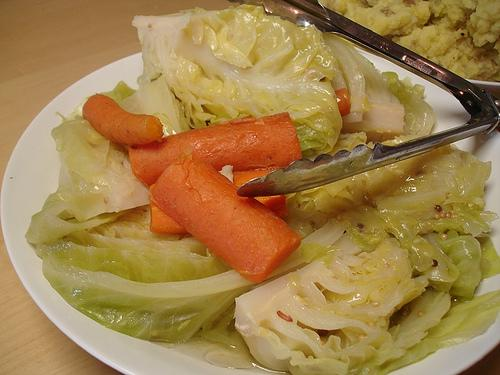What is the visible texture of the table's surface? The table has a visible woodgrain texture and is light tan in color. Identify an object in the background of the image. There is a dish of unidentified fried fish in the background. Based on the visual details of the food, determine if it is cooked or raw. The visual details suggest that the food, both the cabbage, and carrot slices, are cooked. How would you rate the quality of the image's composition? The image composition is well-structured, with a focus on the main objects and proper placement of the background elements. What is the main sentiment evoked by the image of the food presented? The main sentiment evoked by the image is a feeling of a healthy and appetizing meal. Describe the interaction between the tongs and the food on the plate. The silver tongs are resting on top of the heap of cabbage and carrot slices, leaning against the cabbage. What are the main objects in the image and their colors? The main objects in the image are silver tongs, boiled cabbage with a yellow-green color, and orange carrot slices, all on a white round plate on a light tan woodgrained table. Infer a possible reason for the presence of the tongs on the plate. The tongs might be present on the plate to facilitate easy serving or handling of the food. Count the number of carrot pieces on the plate. There are at least 10 pieces of orange carrot on the plate. Provide a detailed description of the food displayed. The food displayed consists of seasoned boiled cabbage and cooked orange carrot segments, piled together on a white round plate, and a silver tongs resting on top of the food. What do you think about the green fork inserted into the seasoned boiled cabbage and carrots? No, it's not mentioned in the image. What is the color and texture of the table the plate is sitting on? The table is light tan in color with a woodgrain texture. Is there any carrot on top of the pile of cabbage? Yes, a piece of orange carrot is on top of the cabbage. Describe the colors and materials of the tongs and the table. The tongs are silver, and the table is light tan with a woodgrain texture. Provide a brief description of the scene in the image. A round white plate with seasoned boiled cabbage and cooked orange carrot segments is placed on a light tan woodgrained table, with silver tongs resting on the food and a dish of fried fish in the background. Based on the image, what kind of activity can you infer is happening or about to happen? Someone is about to serve and eat the cooked vegetables using the silver tongs. Examine the plate holding the food and describe its shape and color. The plate is round and white. What type of vegetable is resting on top of the pile of cabbage? A piece of orange carrot. Write a creative story that is based on the image. Once upon a time in a quaint village, there was a magical cook who could turn any dish into a delicious and healthy treat. One day, as she scrambled to prepare a meal for the visiting queen, she chose a simple combination of boiled cabbage and cooked carrot segments arranged on a round white plate. The cook added secret seasonings that gave the cabbage a yellow-green glow, and she transformed unassuming carrots into radiant orange jewels. A pair of enchanted silver tongs lay atop, eager to serve. Paired with a dish of elusive delicacy, the humble meal enchanted the queen, healing her weariness, and winning her gratitude. Thus, the cook's simple dish became a legend in the village, and her fame spread far and wide. Which object is being used for handling food in the image? silver tongs Create a short poem inspired by the image. In a kitchen warm and bright, What type of food is on the round white plate? A healthy green and yellow cooked vegetable dish, mainly consisting of boiled cabbage and cooked carrot segments. What can you find in the background of the image? A dish of fried fish is in the background. Are the tongs placed on top of the food on the plate, leaning on the cabbage, or beside the plate? leaning on the cabbage What could be the possible event or occasion related to this image? A healthy meal or a vegetable side dish is being prepared for an event or a casual dining experience. What type of dish is placed in the background of the image? A dish of unidentified food, possibly fried fish. Can you recognize any seasoning on the cabbage? Yes, there is visible seasoning on the cabbage. Identify the main vegetables on the plate and describe their colors. There are boiled cabbage, which is yellow-green in color, and cooked carrot segments, which are orange. Describe the appearance of the seasoned cabbage in the image. The seasoned boiled cabbage has a yellow-green color and a white center. 